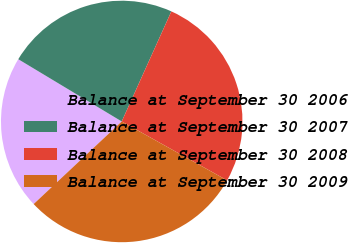<chart> <loc_0><loc_0><loc_500><loc_500><pie_chart><fcel>Balance at September 30 2006<fcel>Balance at September 30 2007<fcel>Balance at September 30 2008<fcel>Balance at September 30 2009<nl><fcel>20.61%<fcel>23.12%<fcel>26.37%<fcel>29.9%<nl></chart> 